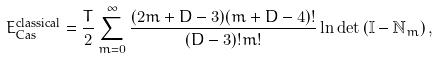<formula> <loc_0><loc_0><loc_500><loc_500>E _ { \text {Cas} } ^ { \text {classical} } = \frac { T } { 2 } \sum _ { m = 0 } ^ { \infty } \frac { ( 2 m + D - 3 ) ( m + D - 4 ) ! } { ( D - 3 ) ! m ! } \ln \det \left ( \mathbb { I } - \mathbb { N } _ { m } \right ) ,</formula> 